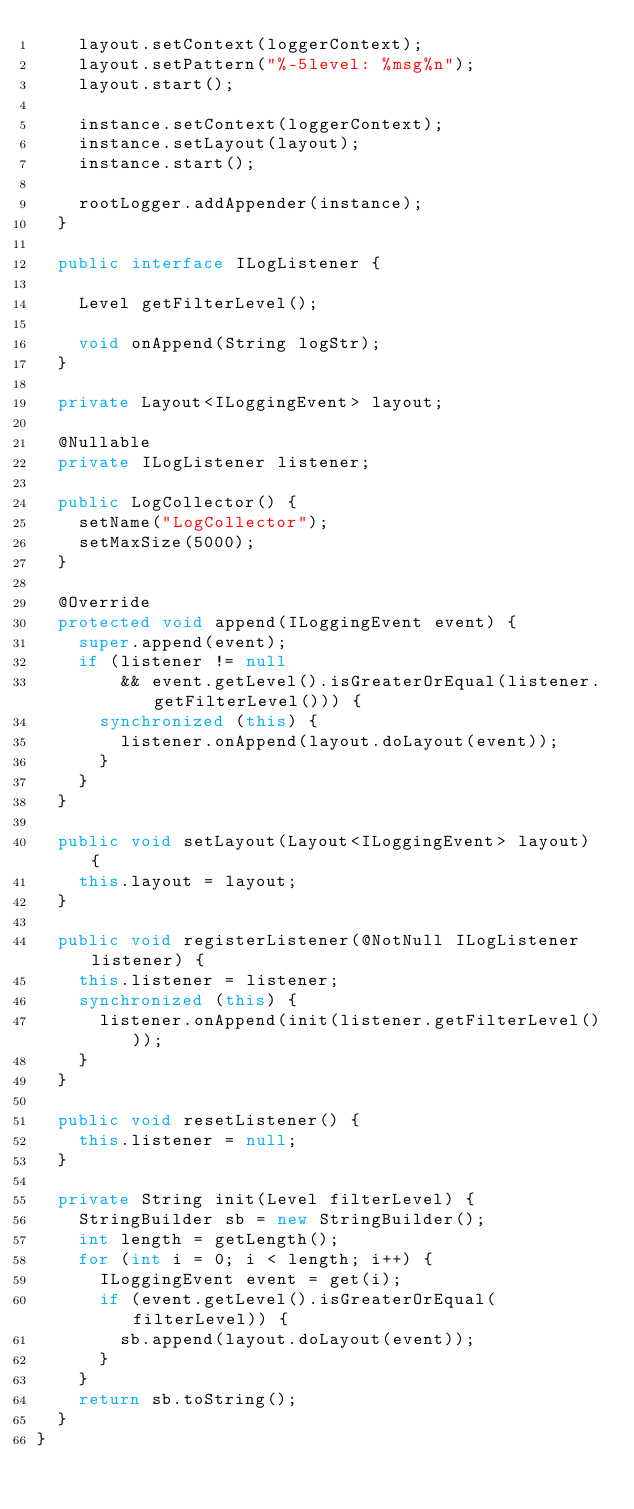Convert code to text. <code><loc_0><loc_0><loc_500><loc_500><_Java_>		layout.setContext(loggerContext);
		layout.setPattern("%-5level: %msg%n");
		layout.start();

		instance.setContext(loggerContext);
		instance.setLayout(layout);
		instance.start();

		rootLogger.addAppender(instance);
	}

	public interface ILogListener {

		Level getFilterLevel();

		void onAppend(String logStr);
	}

	private Layout<ILoggingEvent> layout;

	@Nullable
	private ILogListener listener;

	public LogCollector() {
		setName("LogCollector");
		setMaxSize(5000);
	}

	@Override
	protected void append(ILoggingEvent event) {
		super.append(event);
		if (listener != null
				&& event.getLevel().isGreaterOrEqual(listener.getFilterLevel())) {
			synchronized (this) {
				listener.onAppend(layout.doLayout(event));
			}
		}
	}

	public void setLayout(Layout<ILoggingEvent> layout) {
		this.layout = layout;
	}

	public void registerListener(@NotNull ILogListener listener) {
		this.listener = listener;
		synchronized (this) {
			listener.onAppend(init(listener.getFilterLevel()));
		}
	}

	public void resetListener() {
		this.listener = null;
	}

	private String init(Level filterLevel) {
		StringBuilder sb = new StringBuilder();
		int length = getLength();
		for (int i = 0; i < length; i++) {
			ILoggingEvent event = get(i);
			if (event.getLevel().isGreaterOrEqual(filterLevel)) {
				sb.append(layout.doLayout(event));
			}
		}
		return sb.toString();
	}
}
</code> 